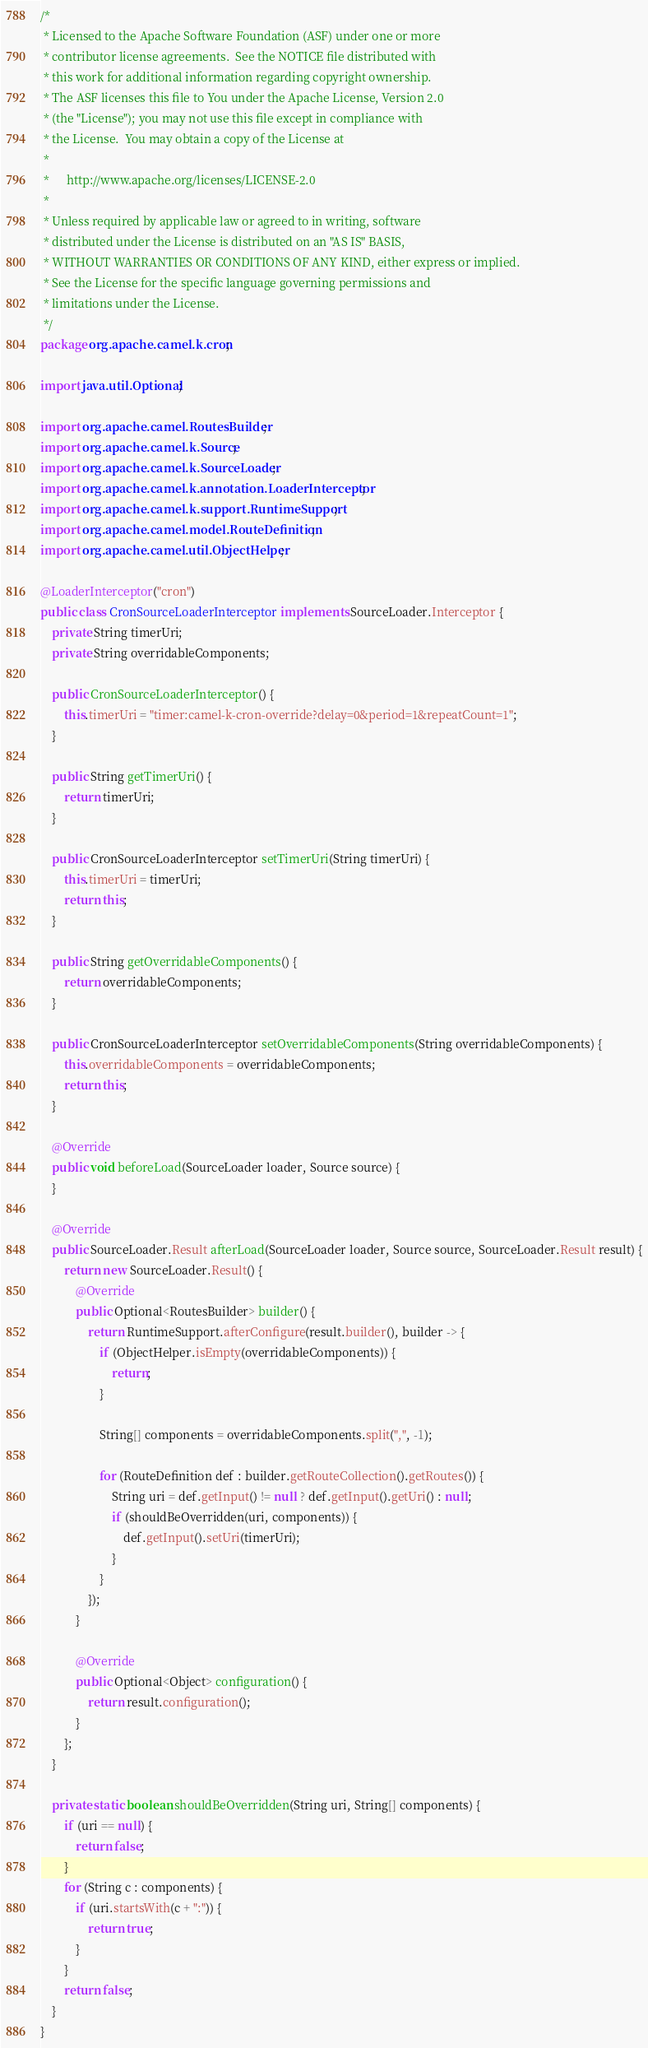Convert code to text. <code><loc_0><loc_0><loc_500><loc_500><_Java_>/*
 * Licensed to the Apache Software Foundation (ASF) under one or more
 * contributor license agreements.  See the NOTICE file distributed with
 * this work for additional information regarding copyright ownership.
 * The ASF licenses this file to You under the Apache License, Version 2.0
 * (the "License"); you may not use this file except in compliance with
 * the License.  You may obtain a copy of the License at
 *
 *      http://www.apache.org/licenses/LICENSE-2.0
 *
 * Unless required by applicable law or agreed to in writing, software
 * distributed under the License is distributed on an "AS IS" BASIS,
 * WITHOUT WARRANTIES OR CONDITIONS OF ANY KIND, either express or implied.
 * See the License for the specific language governing permissions and
 * limitations under the License.
 */
package org.apache.camel.k.cron;

import java.util.Optional;

import org.apache.camel.RoutesBuilder;
import org.apache.camel.k.Source;
import org.apache.camel.k.SourceLoader;
import org.apache.camel.k.annotation.LoaderInterceptor;
import org.apache.camel.k.support.RuntimeSupport;
import org.apache.camel.model.RouteDefinition;
import org.apache.camel.util.ObjectHelper;

@LoaderInterceptor("cron")
public class CronSourceLoaderInterceptor implements SourceLoader.Interceptor {
    private String timerUri;
    private String overridableComponents;

    public CronSourceLoaderInterceptor() {
        this.timerUri = "timer:camel-k-cron-override?delay=0&period=1&repeatCount=1";
    }

    public String getTimerUri() {
        return timerUri;
    }

    public CronSourceLoaderInterceptor setTimerUri(String timerUri) {
        this.timerUri = timerUri;
        return this;
    }

    public String getOverridableComponents() {
        return overridableComponents;
    }

    public CronSourceLoaderInterceptor setOverridableComponents(String overridableComponents) {
        this.overridableComponents = overridableComponents;
        return this;
    }

    @Override
    public void beforeLoad(SourceLoader loader, Source source) {
    }

    @Override
    public SourceLoader.Result afterLoad(SourceLoader loader, Source source, SourceLoader.Result result) {
        return new SourceLoader.Result() {
            @Override
            public Optional<RoutesBuilder> builder() {
                return RuntimeSupport.afterConfigure(result.builder(), builder -> {
                    if (ObjectHelper.isEmpty(overridableComponents)) {
                        return;
                    }

                    String[] components = overridableComponents.split(",", -1);

                    for (RouteDefinition def : builder.getRouteCollection().getRoutes()) {
                        String uri = def.getInput() != null ? def.getInput().getUri() : null;
                        if (shouldBeOverridden(uri, components)) {
                            def.getInput().setUri(timerUri);
                        }
                    }
                });
            }

            @Override
            public Optional<Object> configuration() {
                return result.configuration();
            }
        };
    }

    private static boolean shouldBeOverridden(String uri, String[] components) {
        if (uri == null) {
            return false;
        }
        for (String c : components) {
            if (uri.startsWith(c + ":")) {
                return true;
            }
        }
        return false;
    }
}
</code> 